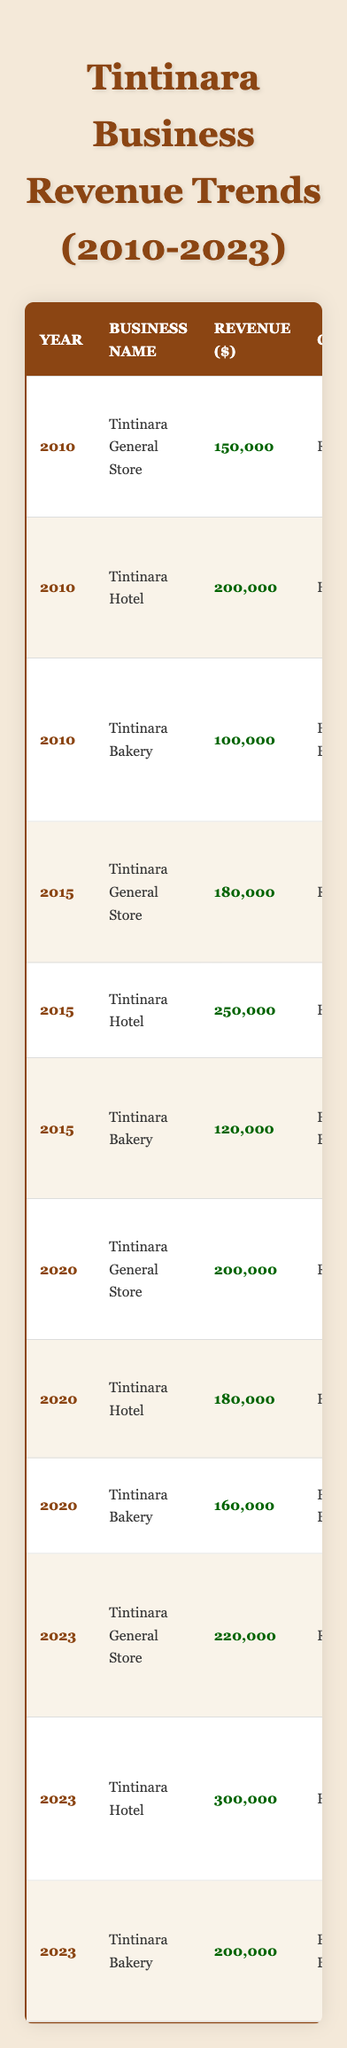What was the revenue of Tintinara Bakery in 2020? The table shows that Tintinara Bakery had a revenue of 160,000 in 2020.
Answer: 160,000 Which business had the highest revenue in 2023? According to the table, Tintinara Hotel had the highest revenue in 2023, with 300,000.
Answer: Tintinara Hotel What was the total revenue of all businesses in Tintinara in 2015? Calculating the total revenue for 2015: General Store (180,000) + Hotel (250,000) + Bakery (120,000) = 550,000.
Answer: 550,000 Did Tintinara General Store's revenue increase from 2010 to 2023? The revenue in 2010 was 150,000 and in 2023 it was 220,000, indicating an increase.
Answer: Yes What is the average revenue of the three businesses in 2023? For 2023: General Store (220,000) + Hotel (300,000) + Bakery (200,000) = 720,000; dividing by 3 gives an average of 240,000.
Answer: 240,000 Which business had consistent growth in revenue from 2010 to 2023? Tintinara General Store had revenues of 150,000 in 2010, 180,000 in 2015, 200,000 in 2020, and 220,000 in 2023, showing consistent growth.
Answer: Tintinara General Store What was the revenue difference between Tintinara Hotel in 2015 and 2020? In 2015, the revenue was 250,000 and in 2020 it was 180,000; the difference is 250,000 - 180,000 = 70,000.
Answer: 70,000 Was the revenue of Tintinara Hotel higher in 2023 than in 2010? The revenue was 300,000 in 2023 and 200,000 in 2010, so it was indeed higher in 2023.
Answer: Yes What is the trend in revenue for Tintinara Bakery from 2010 to 2023? The revenue increased from 100,000 in 2010 to 120,000 in 2015, then to 160,000 in 2020, and finally to 200,000 in 2023, indicating a positive trend.
Answer: Positive trend Which location consistently hosted the businesses mentioned in the table? The data lists three locations: Main Street, High Street, and Church Street. Each business belongs to a location, with Main Street having the General Store, High Street the Hotel, and Church Street the Bakery.
Answer: No single location is consistent for all businesses 